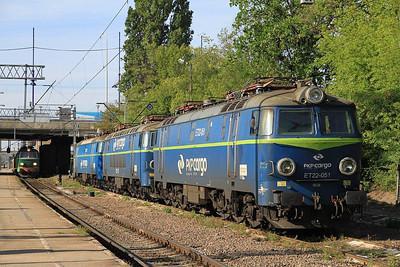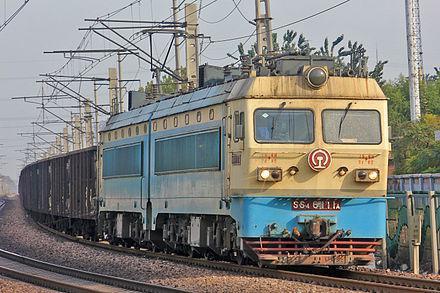The first image is the image on the left, the second image is the image on the right. Examine the images to the left and right. Is the description "All of the trains are facing to the right." accurate? Answer yes or no. Yes. 